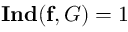Convert formula to latex. <formula><loc_0><loc_0><loc_500><loc_500>I n d ( f , G ) = 1</formula> 